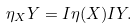<formula> <loc_0><loc_0><loc_500><loc_500>\eta _ { X } Y = I \eta ( X ) I Y .</formula> 